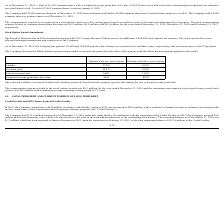From Nordic American Tankers Limited's financial document, What are the number of options granted by the company with vesting over a period of two and three years, respectively?  The document shows two values: 755,000 and 234,000. From the document: "ber 31, 2019, the Company has granted 755,000 and 234,000 options with vesting over a period of two and three years, respectively, and an exercise pri..." Also, What is the exercise price per share of options with vesting over a period of two and three years, respectively granted by the company? The document shows two values: $4.70 and $4.70. From the document: "hree years, respectively, and an exercise price of $4.70 per share...." Also, What are the respective volatility of options with 2 and 3 years vesting? The document shows two values: 57.5% and 52.5%. From the document: "Volatility 57.5% 52.5% Volatility 57.5% 52.5%..." Also, can you calculate: What is the change in Weighted-average grant date fair value between the options with two year vesting and three year vesting? Based on the calculation: 0.59-0.58, the result is 0.01. This is based on the information: "Weighted-average grant date fair value $0.59 $0.58 Weighted-average grant date fair value $0.59 $0.58..." The key data points involved are: 0.58, 0.59. Also, can you calculate: What is the average dividend yield between options with vesting over a period of two and three years? To answer this question, I need to perform calculations using the financial data. The calculation is: (10% + 10%)/2  , which equals 10 (percentage). This is based on the information: "Dividend yield 10.0 % 10.0% Volatility 57.5% 52.5%..." The key data points involved are: 2. Also, can you calculate: What is the average volatility between the options with 2 and 3 years vesting? To answer this question, I need to perform calculations using the financial data. The calculation is: (52.5% + 57.5%)/2 , which equals 55 (percentage). This is based on the information: "Volatility 57.5% 52.5% Volatility 57.5% 52.5% Volatility 57.5% 52.5%..." The key data points involved are: 2, 52.5, 57.5. 